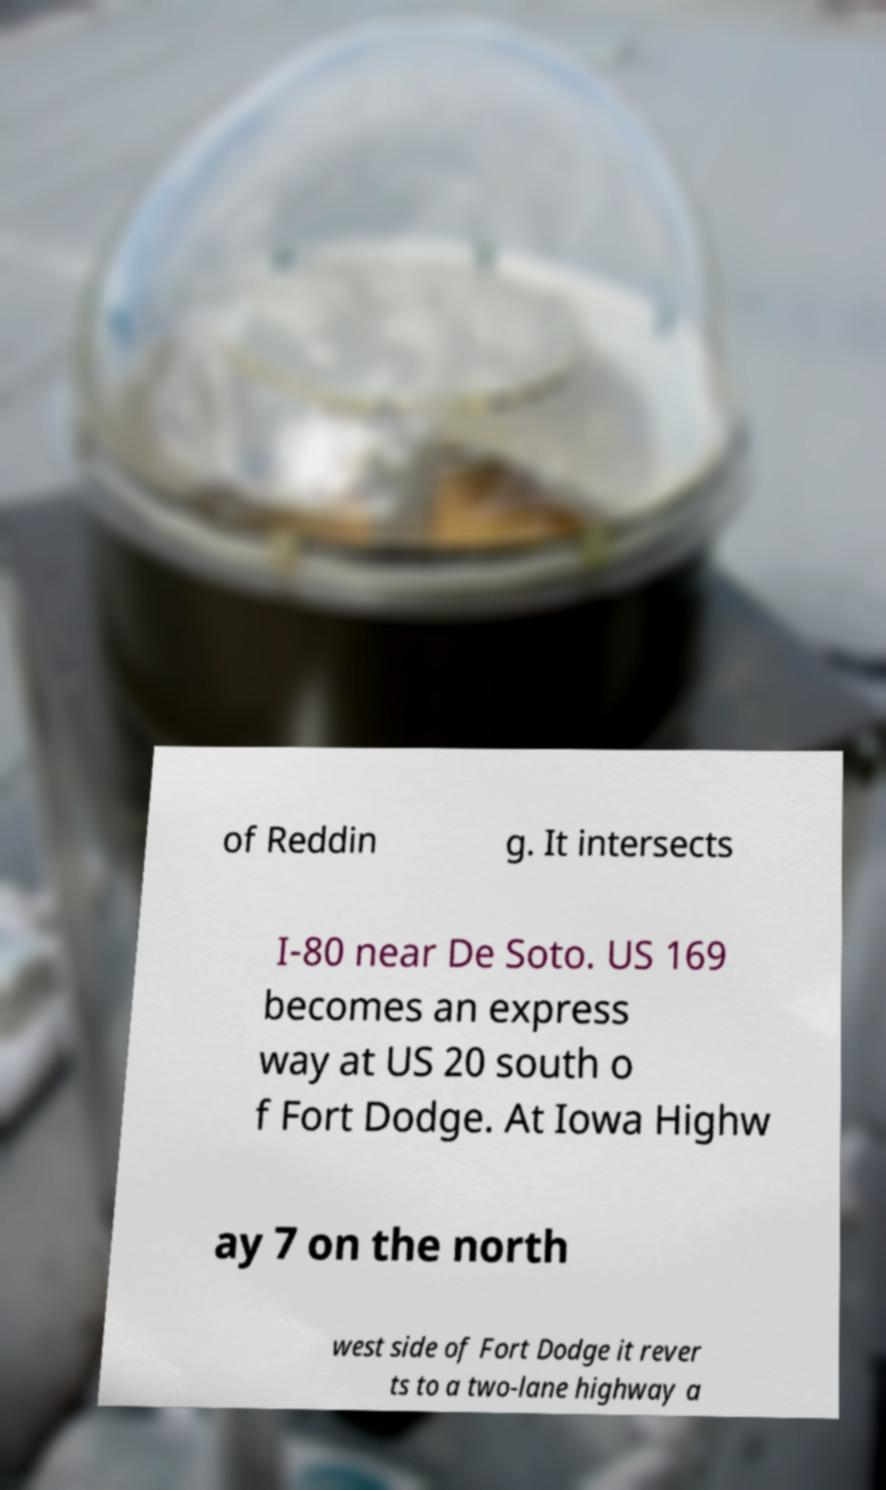Can you accurately transcribe the text from the provided image for me? of Reddin g. It intersects I-80 near De Soto. US 169 becomes an express way at US 20 south o f Fort Dodge. At Iowa Highw ay 7 on the north west side of Fort Dodge it rever ts to a two-lane highway a 